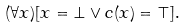<formula> <loc_0><loc_0><loc_500><loc_500>( \forall x ) [ x = \bot \lor c ( x ) = \top ] .</formula> 